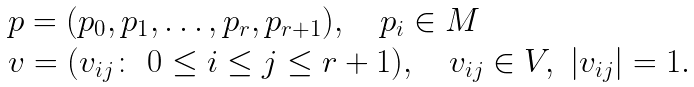<formula> <loc_0><loc_0><loc_500><loc_500>\begin{array} { l } p = ( p _ { 0 } , p _ { 1 } , \dots , p _ { r } , p _ { r + 1 } ) , \quad p _ { i } \in M \\ v = ( v _ { i j } \colon \ 0 \leq i \leq j \leq r + 1 ) , \quad v _ { i j } \in V , \ | v _ { i j } | = 1 . \end{array}</formula> 